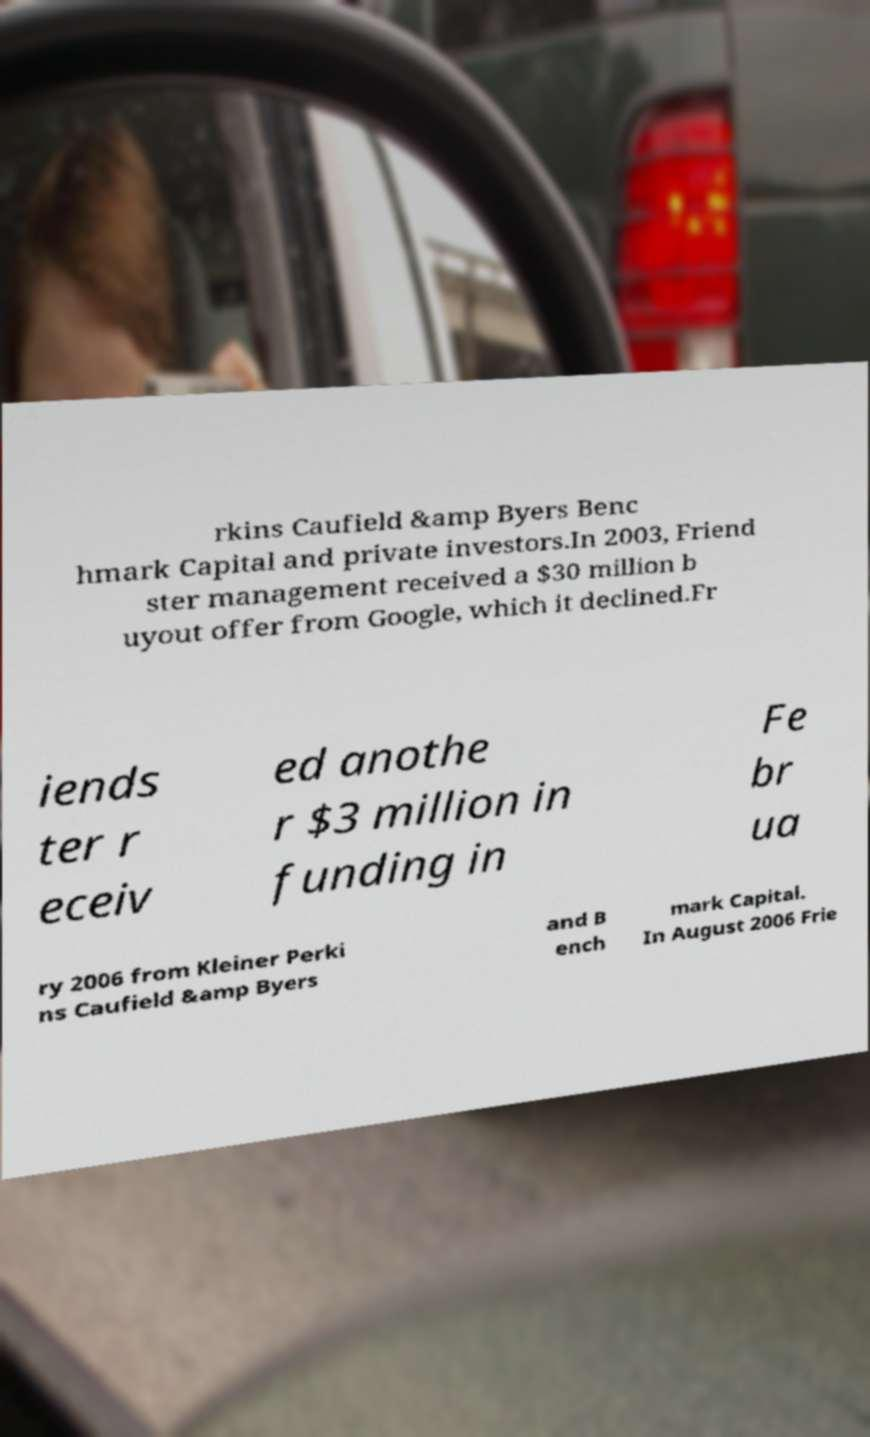Please read and relay the text visible in this image. What does it say? rkins Caufield &amp Byers Benc hmark Capital and private investors.In 2003, Friend ster management received a $30 million b uyout offer from Google, which it declined.Fr iends ter r eceiv ed anothe r $3 million in funding in Fe br ua ry 2006 from Kleiner Perki ns Caufield &amp Byers and B ench mark Capital. In August 2006 Frie 